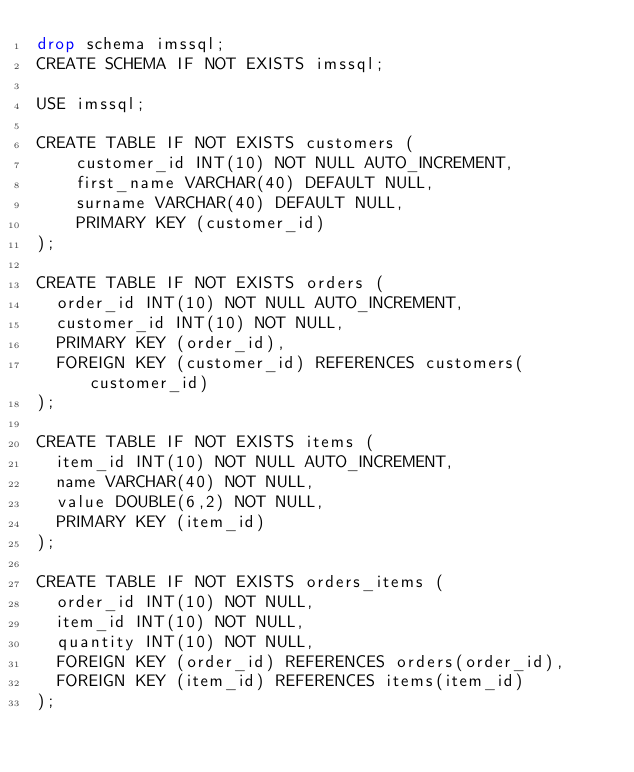<code> <loc_0><loc_0><loc_500><loc_500><_SQL_>drop schema imssql;
CREATE SCHEMA IF NOT EXISTS imssql;

USE imssql;

CREATE TABLE IF NOT EXISTS customers (
    customer_id INT(10) NOT NULL AUTO_INCREMENT,
    first_name VARCHAR(40) DEFAULT NULL,
    surname VARCHAR(40) DEFAULT NULL,
    PRIMARY KEY (customer_id)
);

CREATE TABLE IF NOT EXISTS orders (
	order_id INT(10) NOT NULL AUTO_INCREMENT,
	customer_id INT(10) NOT NULL,
	PRIMARY KEY (order_id),
	FOREIGN KEY (customer_id) REFERENCES customers(customer_id)
);

CREATE TABLE IF NOT EXISTS items (
	item_id INT(10) NOT NULL AUTO_INCREMENT,
	name VARCHAR(40) NOT NULL,
	value DOUBLE(6,2) NOT NULL,
	PRIMARY KEY (item_id)
);	

CREATE TABLE IF NOT EXISTS orders_items (
	order_id INT(10) NOT NULL,
	item_id INT(10) NOT NULL,
	quantity INT(10) NOT NULL,
	FOREIGN KEY (order_id) REFERENCES orders(order_id),
	FOREIGN KEY (item_id) REFERENCES items(item_id)
);</code> 